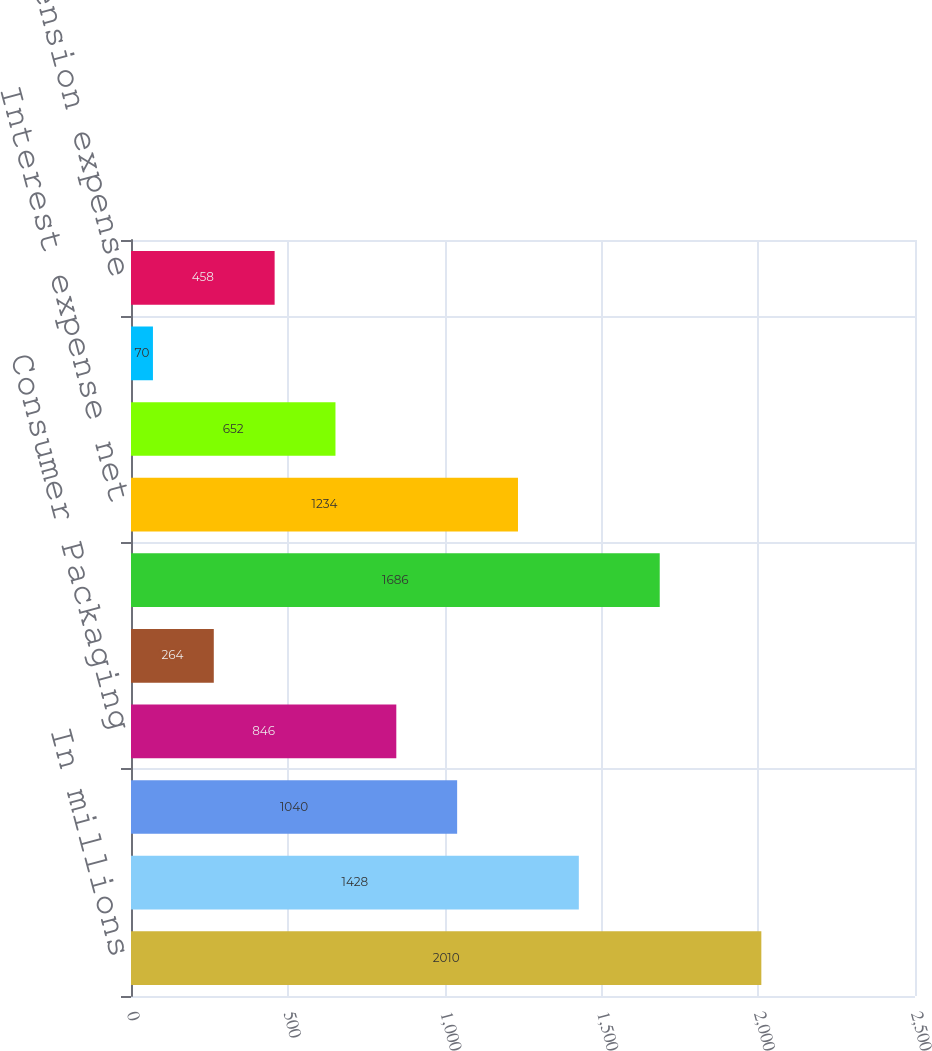Convert chart to OTSL. <chart><loc_0><loc_0><loc_500><loc_500><bar_chart><fcel>In millions<fcel>Industrial Packaging<fcel>Printing Papers<fcel>Consumer Packaging<fcel>Distribution<fcel>Operating Profit<fcel>Interest expense net<fcel>Corporate items net<fcel>Restructuring and other<fcel>Non-operating pension expense<nl><fcel>2010<fcel>1428<fcel>1040<fcel>846<fcel>264<fcel>1686<fcel>1234<fcel>652<fcel>70<fcel>458<nl></chart> 